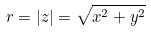Convert formula to latex. <formula><loc_0><loc_0><loc_500><loc_500>r = | z | = \sqrt { x ^ { 2 } + y ^ { 2 } }</formula> 